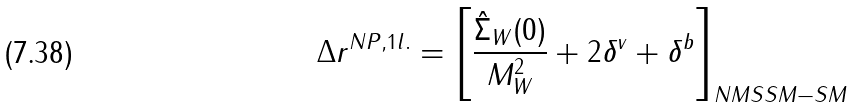Convert formula to latex. <formula><loc_0><loc_0><loc_500><loc_500>\Delta r ^ { N P , 1 l . } = \left [ \frac { \hat { \Sigma } _ { W } ( 0 ) } { M _ { W } ^ { 2 } } + 2 \delta ^ { v } + \delta ^ { b } \right ] _ { N M S S M - S M }</formula> 